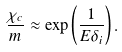Convert formula to latex. <formula><loc_0><loc_0><loc_500><loc_500>\frac { \chi _ { c } } { m } \approx \exp \left ( \frac { 1 } { E \delta _ { i } } \right ) .</formula> 